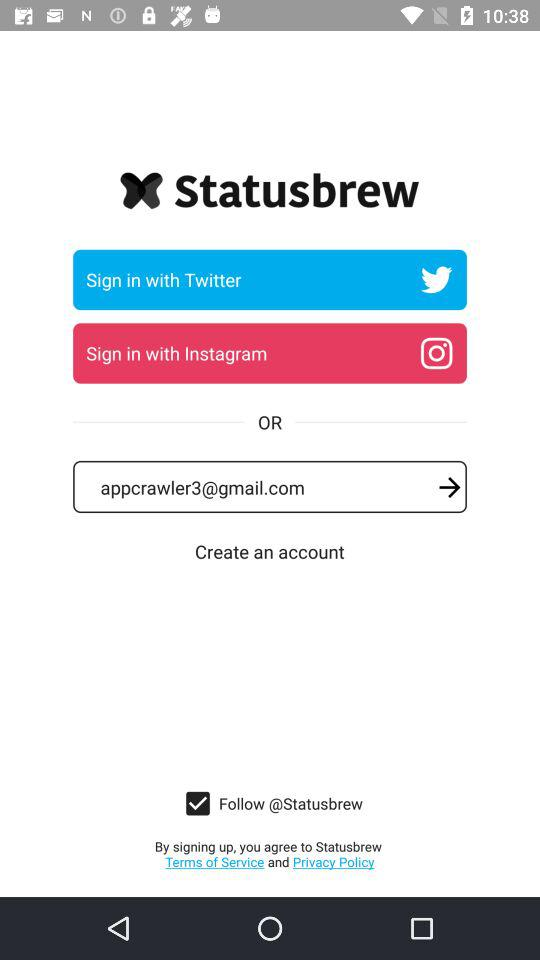What is the status of the "Follow @Statusbrew"? The status is "on". 